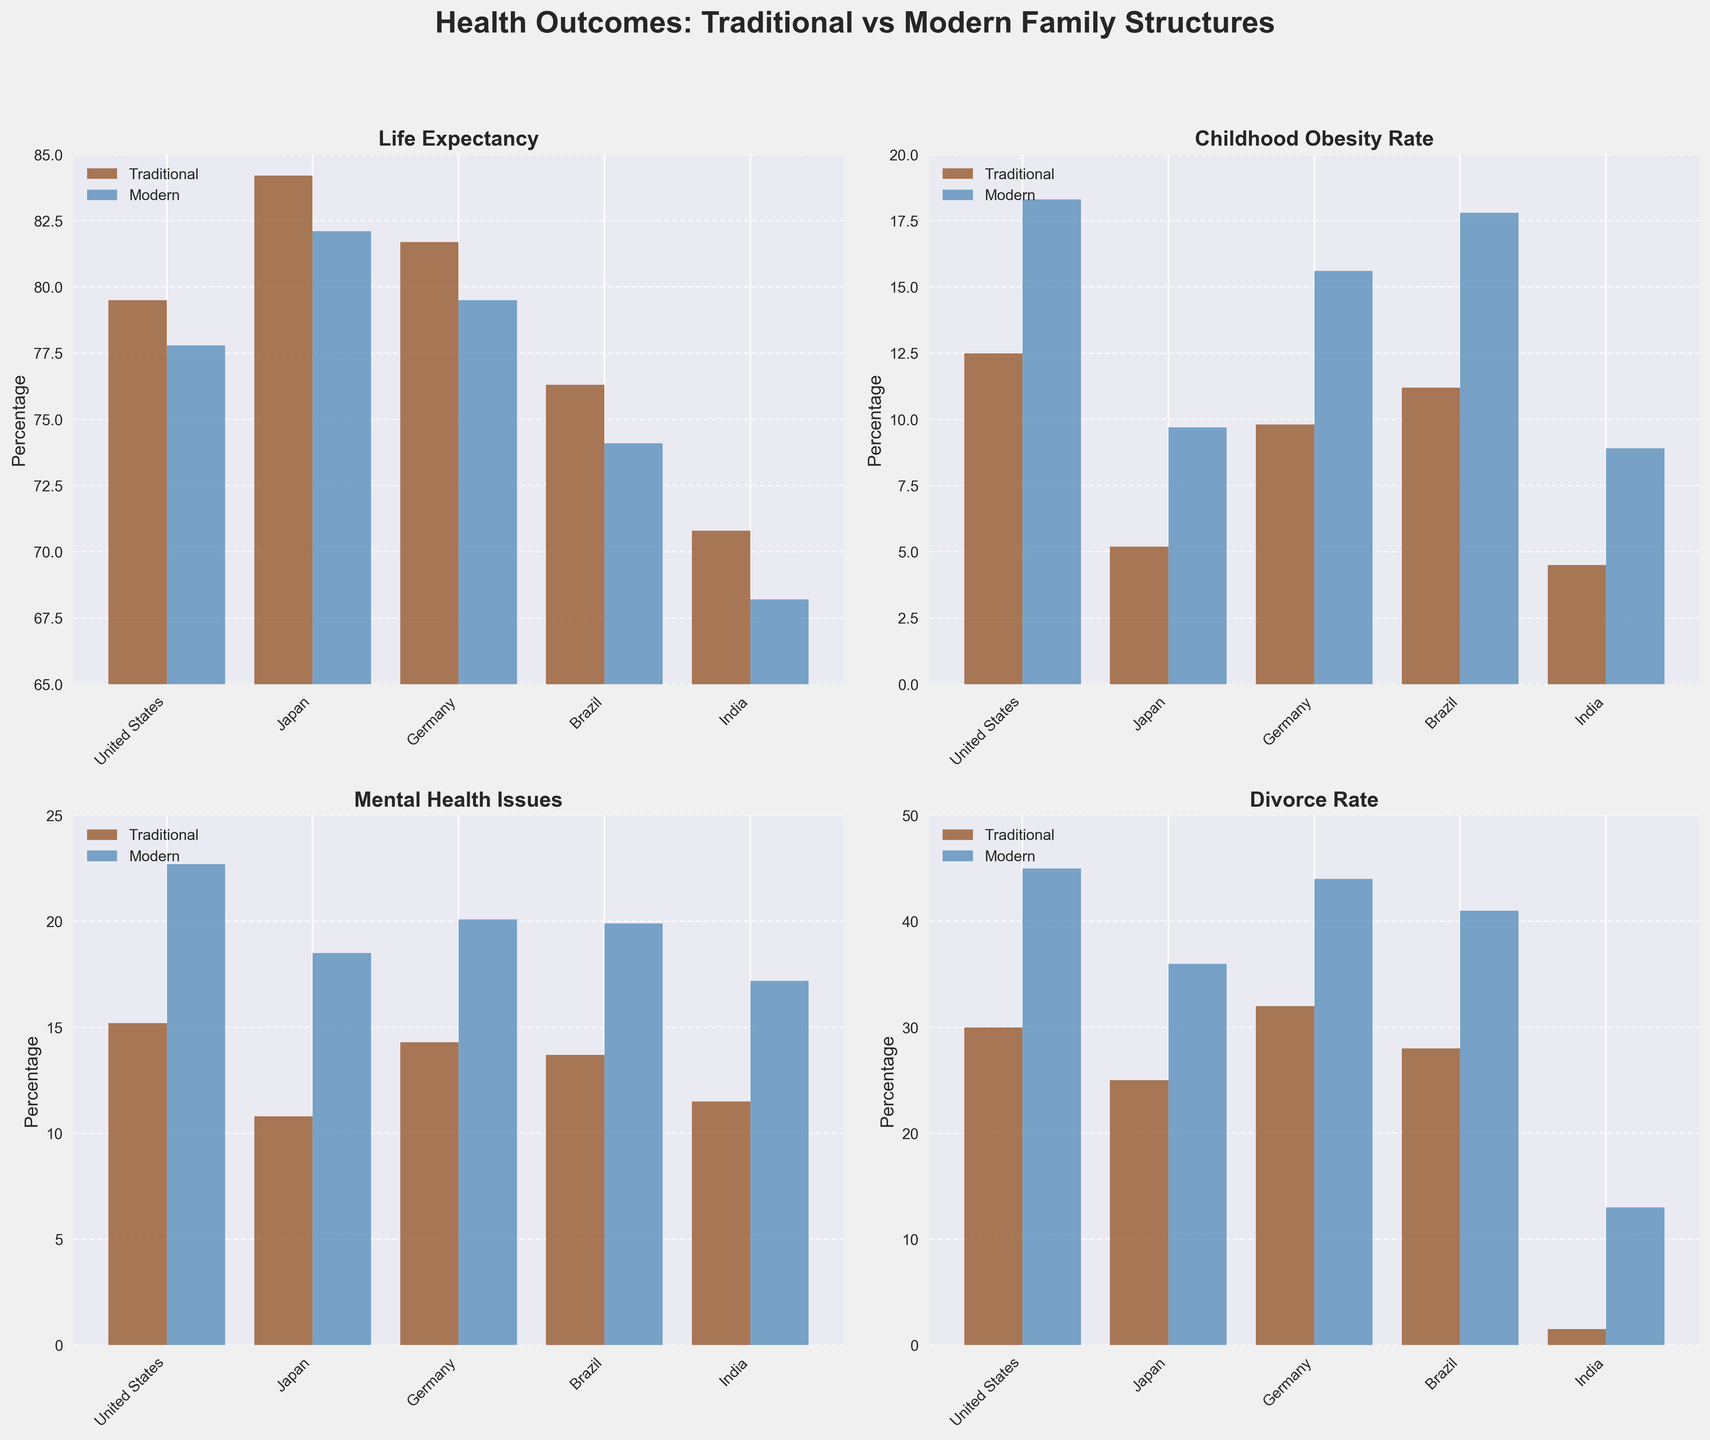What is the title of the figure? The figure's title is mentioned at the top and states the main purpose of the visualization.
Answer: Health Outcomes: Traditional vs Modern Family Structures Which country has the highest Life Expectancy in traditional family structures? From the "Life Expectancy" subplot, locate the highest bar under the "Traditional" group. Japan shows the highest Life Expectancy.
Answer: Japan What is the difference in Childhood Obesity Rate between traditional and modern families in the United States? Locate the "Childhood Obesity Rate" subplot and compare the bar heights for Traditional and Modern families in the United States. Subtract 12.5 (Traditional) from 18.3 (Modern).
Answer: 5.8 Which metric shows the smallest difference between traditional and modern family structures in Germany? Compare the bar heights for both family structures across all subplots and find the smallest difference. Mental Health Issues (14.3 for Traditional and 20.1 for Modern) shows the smallest difference.
Answer: Mental Health Issues Is the Divorce Rate higher in modern families across all countries? Check the "Divorce Rate" subplot and compare the bar heights of Modern and Traditional families for each country. The Divorce Rate is consistently higher in modern families.
Answer: Yes Which country has the largest difference in Mental Health Issues between modern and traditional families? Compare the heights of the bars for Mental Health Issues in all countries and identify the largest gap. Japan (10.8 for Traditional and 18.5 for Modern) shows the largest difference.
Answer: Japan What are the Childhood Obesity Rates in traditional families across all countries? Refer to the "Childhood Obesity Rate" subplot and extract the values for Traditional families: United States (12.5), Japan (5.2), Germany (9.8), Brazil (11.2), and India (4.5).
Answer: 12.5, 5.2, 9.8, 11.2, 4.5 How does Life Expectancy in India compare between traditional and modern family structures? Locate the "Life Expectancy" subplot and compare the values for India. Traditional has 70.8 and Modern has 68.2, showing a higher Life Expectancy in Traditional families.
Answer: Traditional is higher Which country exhibits the lowest Childhood Obesity Rate in modern families? From the "Childhood Obesity Rate" subplot, find the lowest bar in the Modern category. India shows the lowest rate at 8.9.
Answer: India 